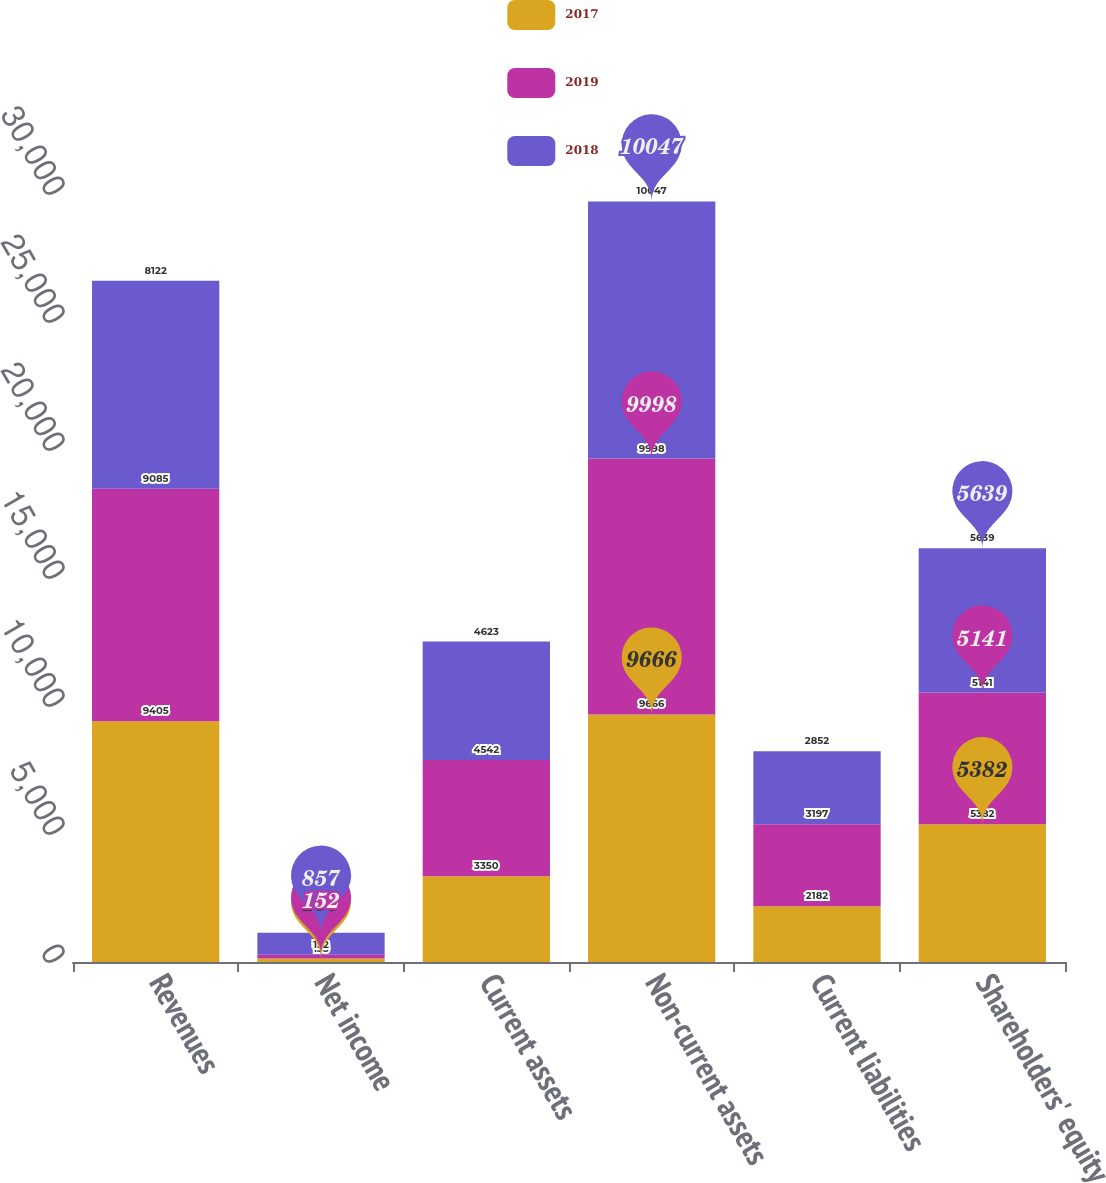<chart> <loc_0><loc_0><loc_500><loc_500><stacked_bar_chart><ecel><fcel>Revenues<fcel>Net income<fcel>Current assets<fcel>Non-current assets<fcel>Current liabilities<fcel>Shareholders' equity<nl><fcel>2017<fcel>9405<fcel>133<fcel>3350<fcel>9666<fcel>2182<fcel>5382<nl><fcel>2019<fcel>9085<fcel>152<fcel>4542<fcel>9998<fcel>3197<fcel>5141<nl><fcel>2018<fcel>8122<fcel>857<fcel>4623<fcel>10047<fcel>2852<fcel>5639<nl></chart> 